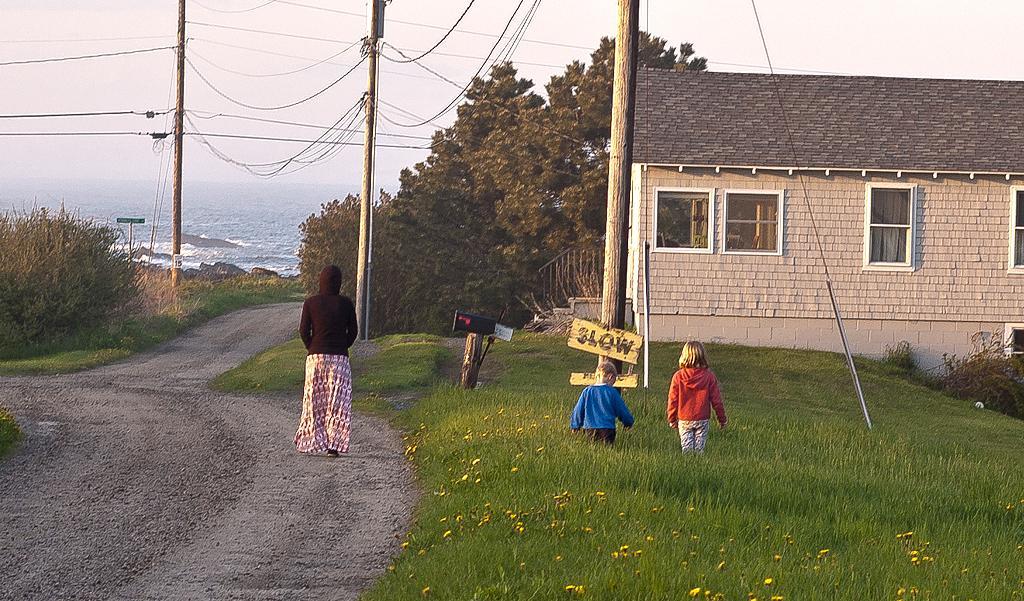How would you summarize this image in a sentence or two? In the center of the image there is a lady walking on the road. There is a house to the right side of the image. There are kids standing on grass. There is a pole with some text on the board. There are electric poles. In the background of the image there is sky, poles, electric wires, water and trees. At the bottom of the image there is road and grass. 